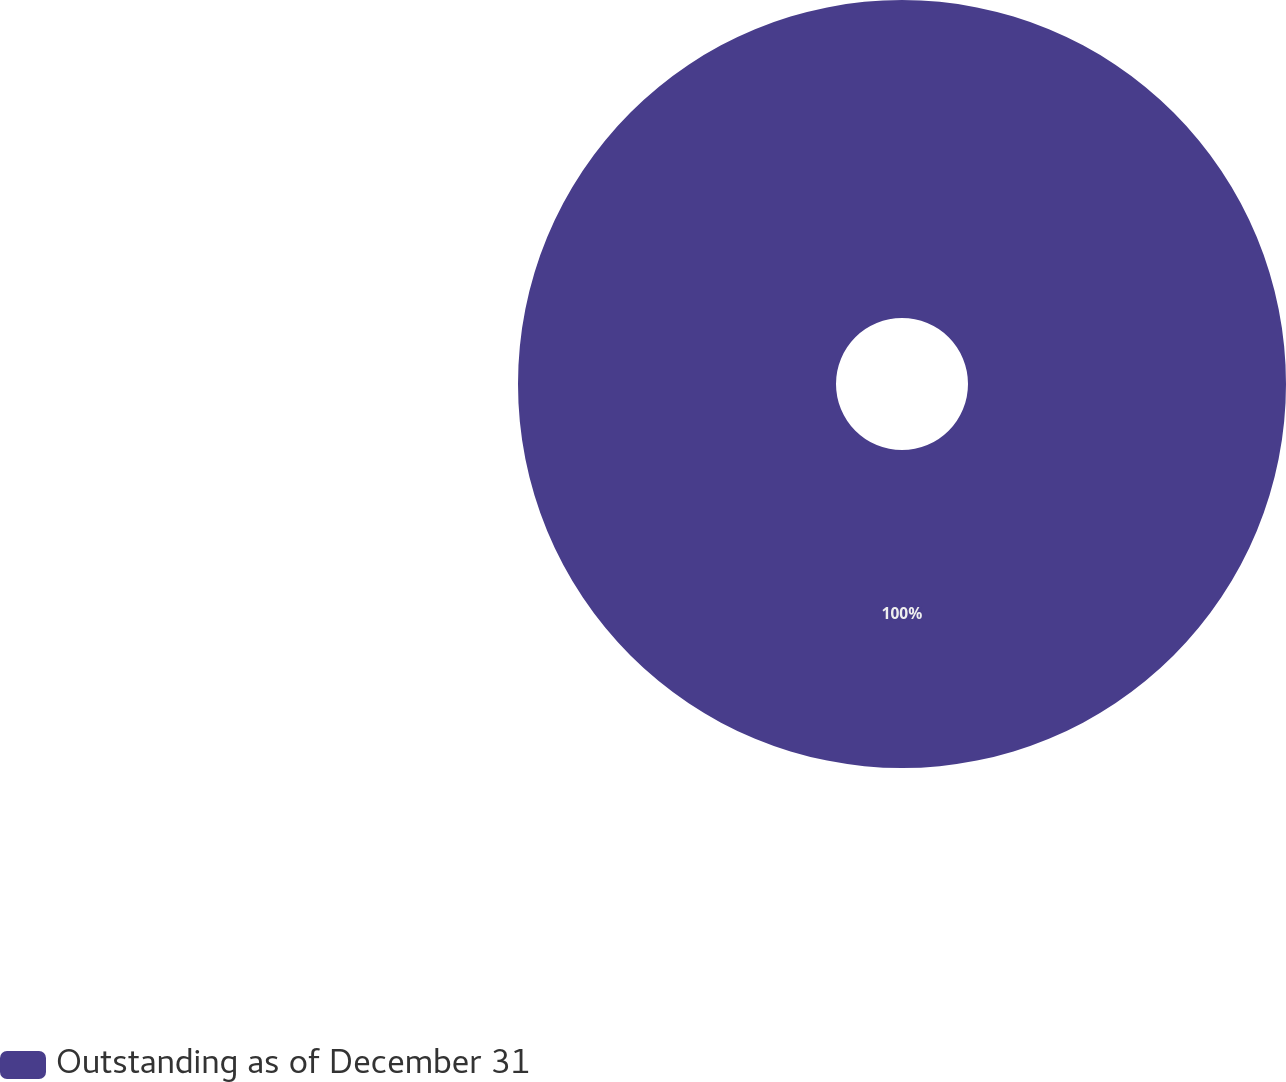Convert chart. <chart><loc_0><loc_0><loc_500><loc_500><pie_chart><fcel>Outstanding as of December 31<nl><fcel>100.0%<nl></chart> 